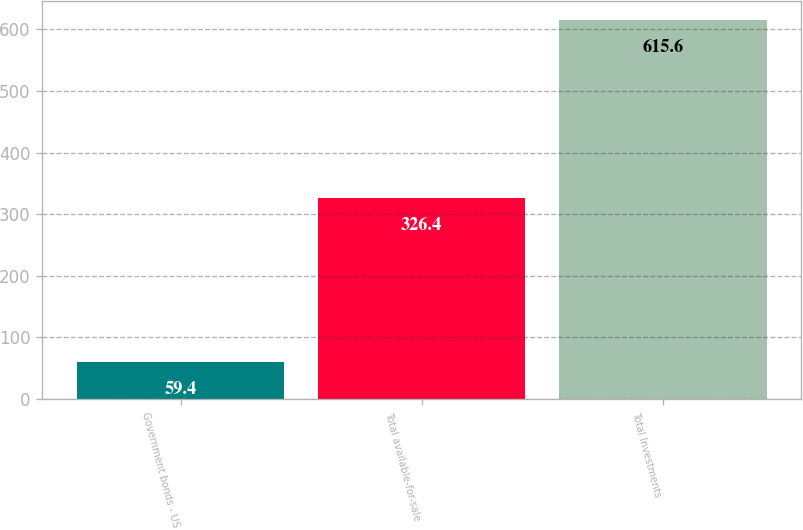<chart> <loc_0><loc_0><loc_500><loc_500><bar_chart><fcel>Government bonds - US<fcel>Total available-for-sale<fcel>Total Investments<nl><fcel>59.4<fcel>326.4<fcel>615.6<nl></chart> 